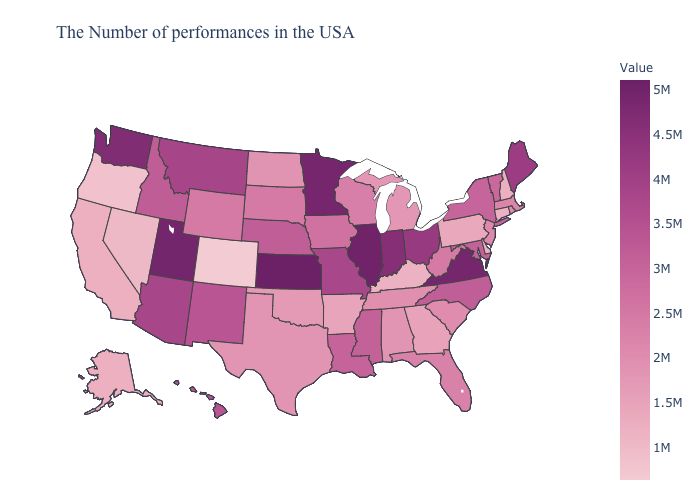Among the states that border South Carolina , does Georgia have the highest value?
Be succinct. No. Which states have the lowest value in the USA?
Concise answer only. Colorado. Does Pennsylvania have a higher value than Oregon?
Be succinct. Yes. Is the legend a continuous bar?
Short answer required. Yes. 